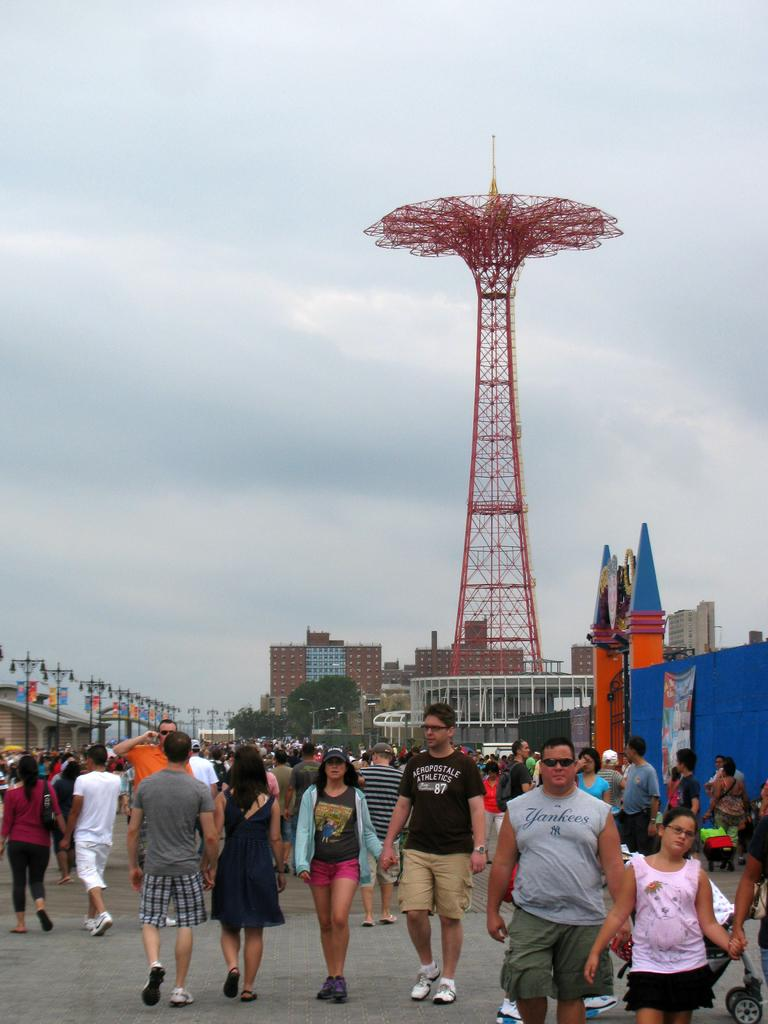What is happening in the image? There are many people walking around in the image. What structures can be seen in the image? There are buildings in the middle of the image, and a tower on the right side of the image. What is visible in the background of the image? The background of the image is the sky. Can you see any yarn being used by the people in the image? There is no yarn present in the image. Are there any squirrels attempting to climb the tower in the image? There are no squirrels present in the image. 